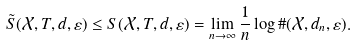<formula> <loc_0><loc_0><loc_500><loc_500>\tilde { S } ( \mathcal { X } , T , d , \varepsilon ) \leq S ( \mathcal { X } , T , d , \varepsilon ) = \lim _ { n \to \infty } \frac { 1 } { n } \log \# ( \mathcal { X } , d _ { n } , \varepsilon ) .</formula> 